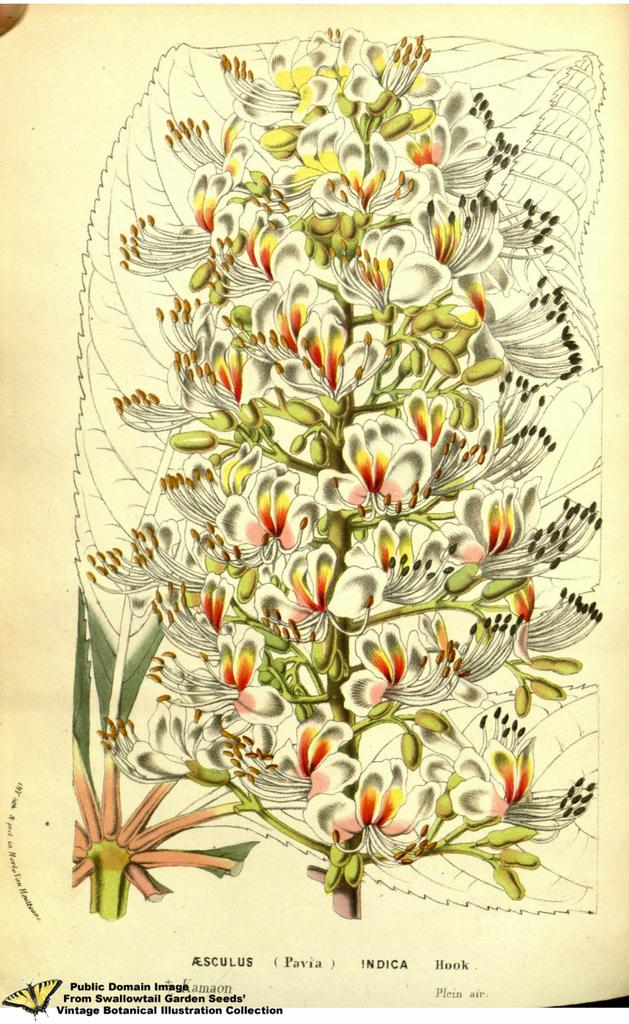What is the main subject of the image? The main subject of the image is a paper. What is depicted on the paper? There is a painting of a plant on the paper. Can you describe the plant in the painting? The painting includes flowers and buds. Is there any text present in the image? Yes, there is text at the bottom of the image. What type of body part is shown interacting with the painting in the image? There are no body parts present in the image; it only contains a paper with a painting and text. What record is being played in the image? There is no record or music player present in the image. 